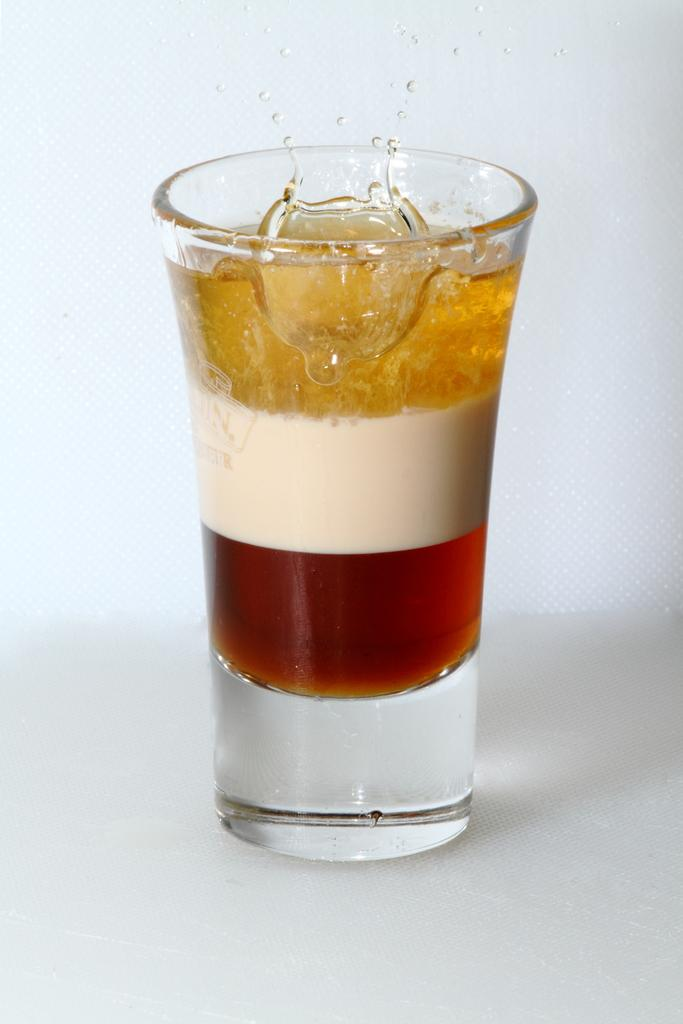What is present in the image that can hold liquids? There is a glass in the image. What can be observed inside the glass? The glass contains three color liquids. What is the tooth's design in the image? There is no tooth present in the image. 